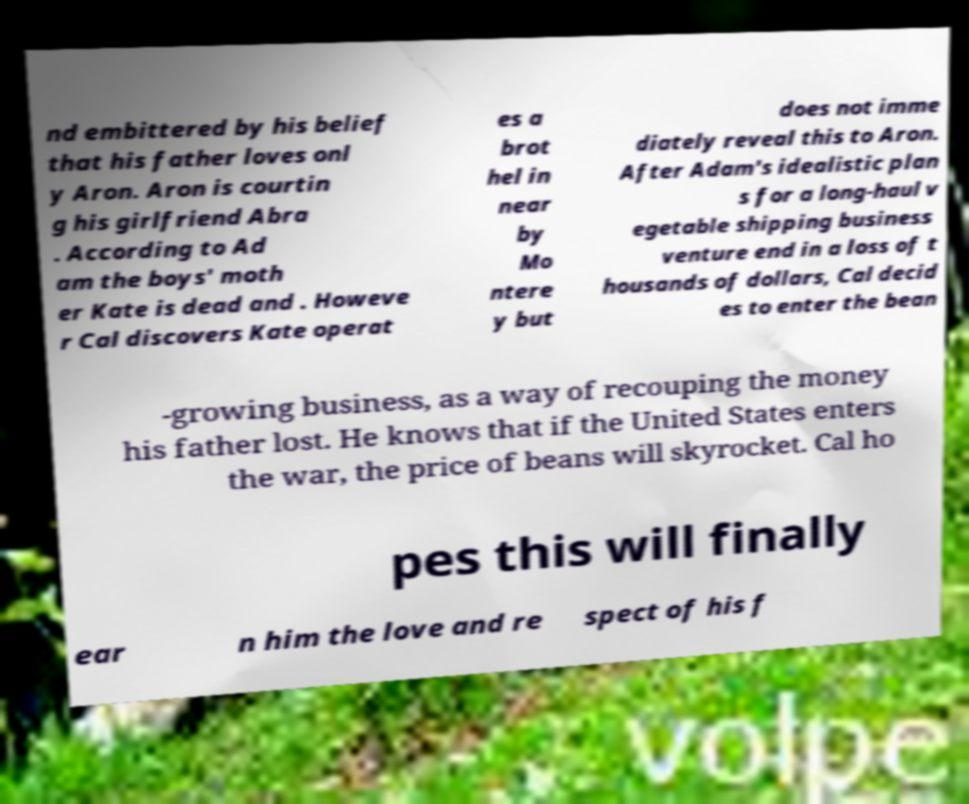Please identify and transcribe the text found in this image. nd embittered by his belief that his father loves onl y Aron. Aron is courtin g his girlfriend Abra . According to Ad am the boys' moth er Kate is dead and . Howeve r Cal discovers Kate operat es a brot hel in near by Mo ntere y but does not imme diately reveal this to Aron. After Adam's idealistic plan s for a long-haul v egetable shipping business venture end in a loss of t housands of dollars, Cal decid es to enter the bean -growing business, as a way of recouping the money his father lost. He knows that if the United States enters the war, the price of beans will skyrocket. Cal ho pes this will finally ear n him the love and re spect of his f 